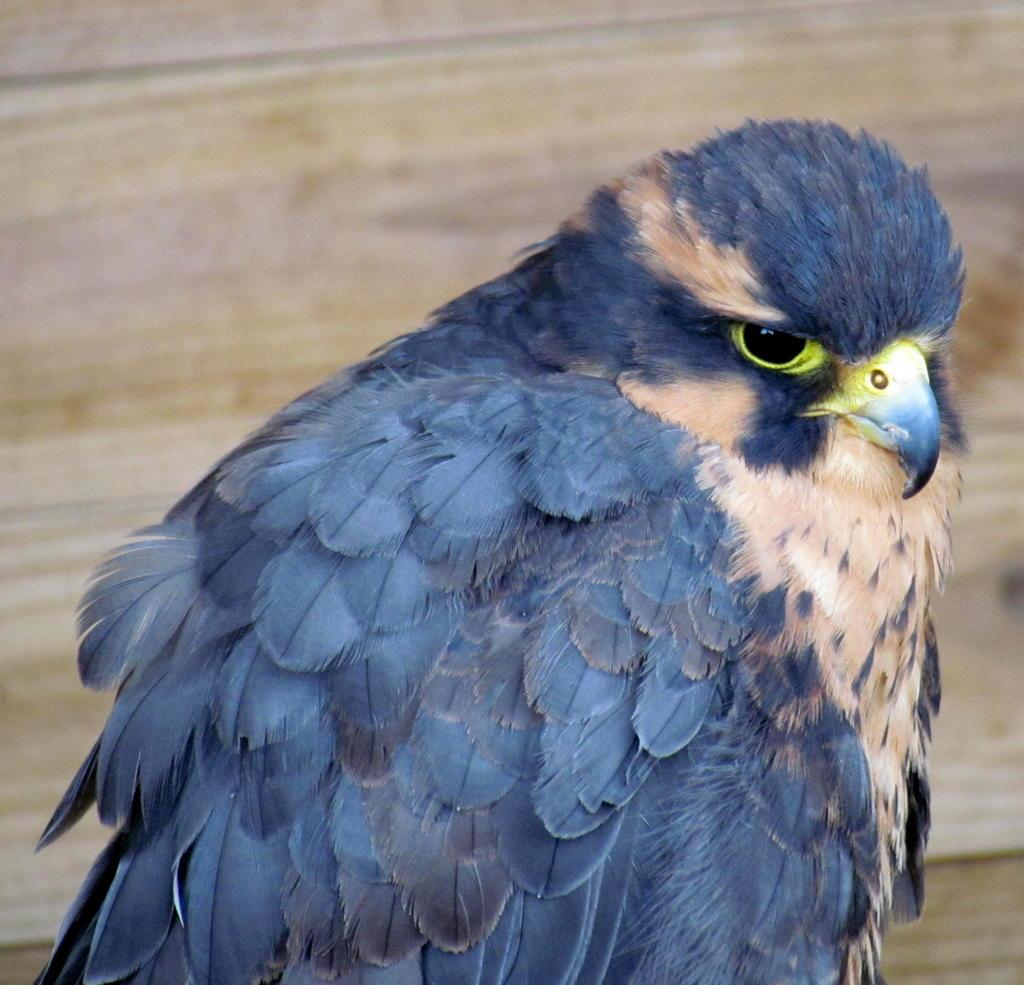What type of animal can be seen in the image? There is a bird in the image. Can you describe the background of the image? The background of the image is blurry. What type of stocking is the bird wearing in the image? There is no stocking present on the bird in the image. 